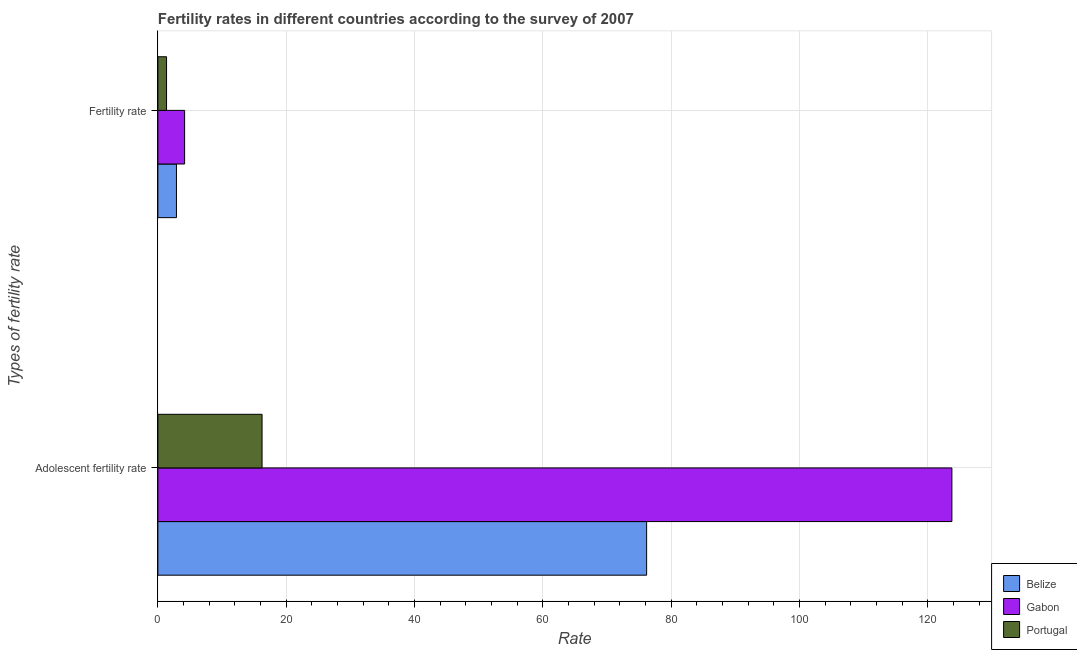Are the number of bars per tick equal to the number of legend labels?
Make the answer very short. Yes. Are the number of bars on each tick of the Y-axis equal?
Ensure brevity in your answer.  Yes. What is the label of the 2nd group of bars from the top?
Keep it short and to the point. Adolescent fertility rate. What is the adolescent fertility rate in Belize?
Your response must be concise. 76.17. Across all countries, what is the maximum fertility rate?
Provide a succinct answer. 4.16. Across all countries, what is the minimum adolescent fertility rate?
Your answer should be very brief. 16.24. In which country was the adolescent fertility rate maximum?
Ensure brevity in your answer.  Gabon. What is the total adolescent fertility rate in the graph?
Offer a very short reply. 216.15. What is the difference between the fertility rate in Belize and that in Portugal?
Make the answer very short. 1.54. What is the difference between the adolescent fertility rate in Portugal and the fertility rate in Belize?
Ensure brevity in your answer.  13.34. What is the average fertility rate per country?
Your answer should be very brief. 2.8. What is the difference between the adolescent fertility rate and fertility rate in Belize?
Give a very brief answer. 73.28. In how many countries, is the fertility rate greater than 12 ?
Provide a succinct answer. 0. What is the ratio of the fertility rate in Belize to that in Gabon?
Provide a short and direct response. 0.69. In how many countries, is the adolescent fertility rate greater than the average adolescent fertility rate taken over all countries?
Offer a terse response. 2. What does the 3rd bar from the top in Adolescent fertility rate represents?
Make the answer very short. Belize. How many bars are there?
Your response must be concise. 6. How many countries are there in the graph?
Your answer should be compact. 3. What is the difference between two consecutive major ticks on the X-axis?
Offer a terse response. 20. Does the graph contain grids?
Provide a short and direct response. Yes. How are the legend labels stacked?
Give a very brief answer. Vertical. What is the title of the graph?
Provide a succinct answer. Fertility rates in different countries according to the survey of 2007. Does "South Africa" appear as one of the legend labels in the graph?
Your response must be concise. No. What is the label or title of the X-axis?
Keep it short and to the point. Rate. What is the label or title of the Y-axis?
Make the answer very short. Types of fertility rate. What is the Rate in Belize in Adolescent fertility rate?
Ensure brevity in your answer.  76.17. What is the Rate in Gabon in Adolescent fertility rate?
Your answer should be very brief. 123.75. What is the Rate in Portugal in Adolescent fertility rate?
Provide a short and direct response. 16.24. What is the Rate of Belize in Fertility rate?
Provide a succinct answer. 2.89. What is the Rate in Gabon in Fertility rate?
Provide a succinct answer. 4.16. What is the Rate of Portugal in Fertility rate?
Your response must be concise. 1.35. Across all Types of fertility rate, what is the maximum Rate of Belize?
Offer a very short reply. 76.17. Across all Types of fertility rate, what is the maximum Rate in Gabon?
Keep it short and to the point. 123.75. Across all Types of fertility rate, what is the maximum Rate of Portugal?
Give a very brief answer. 16.24. Across all Types of fertility rate, what is the minimum Rate in Belize?
Your answer should be compact. 2.89. Across all Types of fertility rate, what is the minimum Rate in Gabon?
Your answer should be compact. 4.16. Across all Types of fertility rate, what is the minimum Rate of Portugal?
Make the answer very short. 1.35. What is the total Rate of Belize in the graph?
Make the answer very short. 79.06. What is the total Rate of Gabon in the graph?
Provide a short and direct response. 127.91. What is the total Rate of Portugal in the graph?
Make the answer very short. 17.59. What is the difference between the Rate of Belize in Adolescent fertility rate and that in Fertility rate?
Offer a terse response. 73.28. What is the difference between the Rate in Gabon in Adolescent fertility rate and that in Fertility rate?
Your answer should be compact. 119.58. What is the difference between the Rate of Portugal in Adolescent fertility rate and that in Fertility rate?
Make the answer very short. 14.89. What is the difference between the Rate of Belize in Adolescent fertility rate and the Rate of Gabon in Fertility rate?
Provide a short and direct response. 72. What is the difference between the Rate of Belize in Adolescent fertility rate and the Rate of Portugal in Fertility rate?
Give a very brief answer. 74.82. What is the difference between the Rate in Gabon in Adolescent fertility rate and the Rate in Portugal in Fertility rate?
Provide a succinct answer. 122.39. What is the average Rate of Belize per Types of fertility rate?
Provide a short and direct response. 39.53. What is the average Rate in Gabon per Types of fertility rate?
Your answer should be compact. 63.95. What is the average Rate of Portugal per Types of fertility rate?
Offer a very short reply. 8.79. What is the difference between the Rate in Belize and Rate in Gabon in Adolescent fertility rate?
Keep it short and to the point. -47.58. What is the difference between the Rate in Belize and Rate in Portugal in Adolescent fertility rate?
Ensure brevity in your answer.  59.93. What is the difference between the Rate in Gabon and Rate in Portugal in Adolescent fertility rate?
Make the answer very short. 107.51. What is the difference between the Rate of Belize and Rate of Gabon in Fertility rate?
Your response must be concise. -1.27. What is the difference between the Rate of Belize and Rate of Portugal in Fertility rate?
Provide a succinct answer. 1.54. What is the difference between the Rate in Gabon and Rate in Portugal in Fertility rate?
Offer a terse response. 2.81. What is the ratio of the Rate in Belize in Adolescent fertility rate to that in Fertility rate?
Offer a terse response. 26.33. What is the ratio of the Rate in Gabon in Adolescent fertility rate to that in Fertility rate?
Your answer should be compact. 29.72. What is the ratio of the Rate in Portugal in Adolescent fertility rate to that in Fertility rate?
Make the answer very short. 12.03. What is the difference between the highest and the second highest Rate in Belize?
Your answer should be compact. 73.28. What is the difference between the highest and the second highest Rate of Gabon?
Your answer should be very brief. 119.58. What is the difference between the highest and the second highest Rate of Portugal?
Give a very brief answer. 14.89. What is the difference between the highest and the lowest Rate of Belize?
Your answer should be very brief. 73.28. What is the difference between the highest and the lowest Rate in Gabon?
Offer a very short reply. 119.58. What is the difference between the highest and the lowest Rate in Portugal?
Provide a succinct answer. 14.89. 